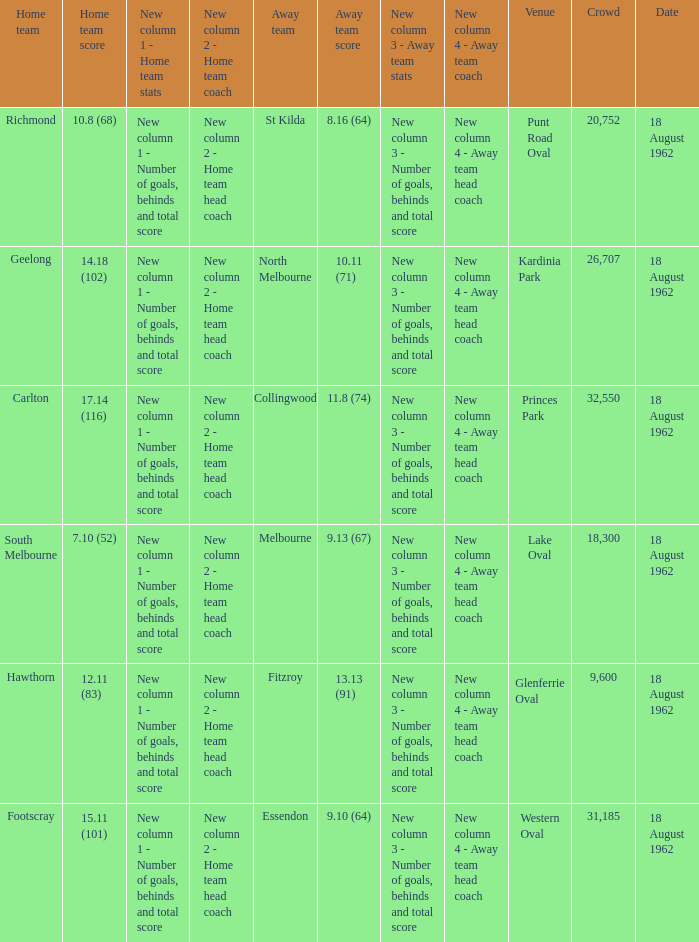What was the away team when the home team scored 10.8 (68)? St Kilda. 